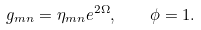<formula> <loc_0><loc_0><loc_500><loc_500>g _ { m n } = \eta _ { m n } e ^ { 2 \Omega } , \quad \phi = 1 .</formula> 